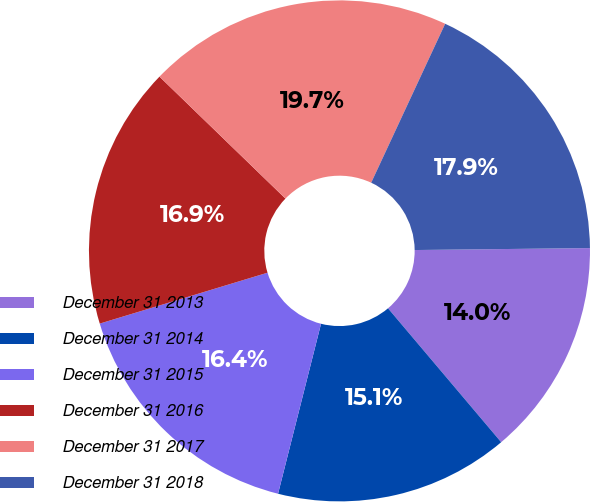<chart> <loc_0><loc_0><loc_500><loc_500><pie_chart><fcel>December 31 2013<fcel>December 31 2014<fcel>December 31 2015<fcel>December 31 2016<fcel>December 31 2017<fcel>December 31 2018<nl><fcel>14.01%<fcel>15.11%<fcel>16.37%<fcel>16.93%<fcel>19.69%<fcel>17.89%<nl></chart> 